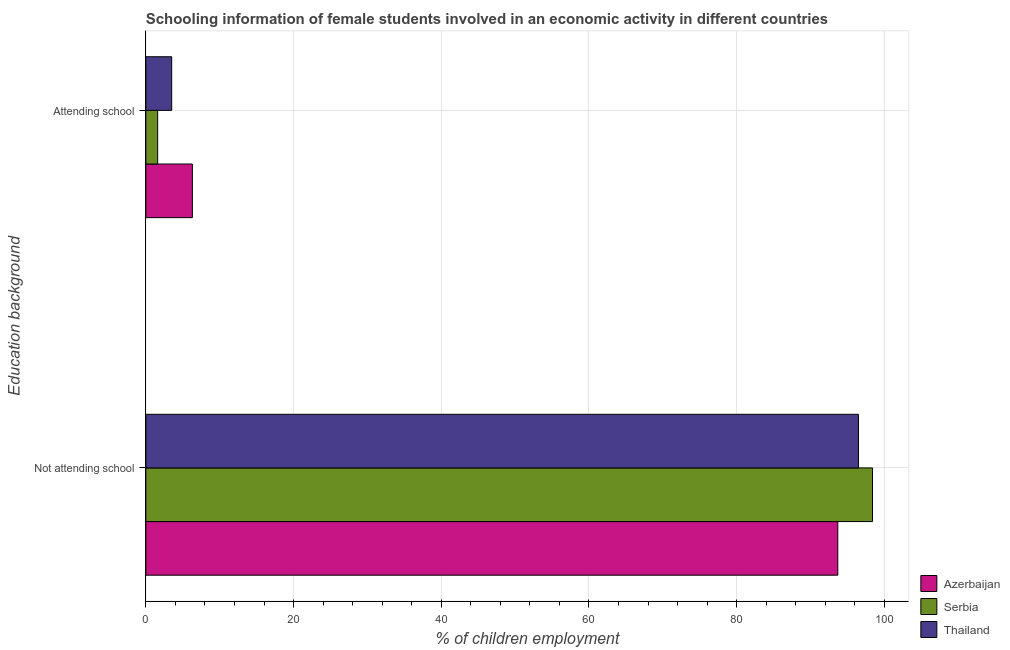Are the number of bars per tick equal to the number of legend labels?
Offer a very short reply. Yes. How many bars are there on the 2nd tick from the bottom?
Keep it short and to the point. 3. What is the label of the 1st group of bars from the top?
Offer a very short reply. Attending school. What is the percentage of employed females who are attending school in Thailand?
Your answer should be compact. 3.5. Across all countries, what is the maximum percentage of employed females who are not attending school?
Keep it short and to the point. 98.4. Across all countries, what is the minimum percentage of employed females who are not attending school?
Ensure brevity in your answer.  93.7. In which country was the percentage of employed females who are attending school maximum?
Offer a terse response. Azerbaijan. In which country was the percentage of employed females who are attending school minimum?
Your answer should be compact. Serbia. What is the total percentage of employed females who are attending school in the graph?
Your response must be concise. 11.4. What is the difference between the percentage of employed females who are attending school in Azerbaijan and that in Thailand?
Make the answer very short. 2.8. What is the difference between the percentage of employed females who are not attending school in Serbia and the percentage of employed females who are attending school in Thailand?
Your answer should be compact. 94.9. What is the average percentage of employed females who are not attending school per country?
Ensure brevity in your answer.  96.2. What is the difference between the percentage of employed females who are attending school and percentage of employed females who are not attending school in Serbia?
Make the answer very short. -96.8. What is the ratio of the percentage of employed females who are not attending school in Azerbaijan to that in Thailand?
Your response must be concise. 0.97. Is the percentage of employed females who are not attending school in Azerbaijan less than that in Thailand?
Your response must be concise. Yes. What does the 2nd bar from the top in Not attending school represents?
Your answer should be compact. Serbia. What does the 3rd bar from the bottom in Attending school represents?
Make the answer very short. Thailand. How many countries are there in the graph?
Your response must be concise. 3. Are the values on the major ticks of X-axis written in scientific E-notation?
Give a very brief answer. No. Does the graph contain any zero values?
Offer a terse response. No. Does the graph contain grids?
Offer a terse response. Yes. Where does the legend appear in the graph?
Give a very brief answer. Bottom right. How are the legend labels stacked?
Your answer should be very brief. Vertical. What is the title of the graph?
Offer a terse response. Schooling information of female students involved in an economic activity in different countries. What is the label or title of the X-axis?
Keep it short and to the point. % of children employment. What is the label or title of the Y-axis?
Provide a succinct answer. Education background. What is the % of children employment in Azerbaijan in Not attending school?
Your answer should be very brief. 93.7. What is the % of children employment of Serbia in Not attending school?
Keep it short and to the point. 98.4. What is the % of children employment in Thailand in Not attending school?
Give a very brief answer. 96.5. What is the % of children employment of Thailand in Attending school?
Ensure brevity in your answer.  3.5. Across all Education background, what is the maximum % of children employment in Azerbaijan?
Your answer should be very brief. 93.7. Across all Education background, what is the maximum % of children employment of Serbia?
Make the answer very short. 98.4. Across all Education background, what is the maximum % of children employment in Thailand?
Give a very brief answer. 96.5. Across all Education background, what is the minimum % of children employment of Serbia?
Give a very brief answer. 1.6. Across all Education background, what is the minimum % of children employment in Thailand?
Give a very brief answer. 3.5. What is the total % of children employment in Azerbaijan in the graph?
Your answer should be compact. 100. What is the total % of children employment of Serbia in the graph?
Offer a terse response. 100. What is the total % of children employment of Thailand in the graph?
Offer a terse response. 100. What is the difference between the % of children employment in Azerbaijan in Not attending school and that in Attending school?
Make the answer very short. 87.4. What is the difference between the % of children employment in Serbia in Not attending school and that in Attending school?
Give a very brief answer. 96.8. What is the difference between the % of children employment of Thailand in Not attending school and that in Attending school?
Give a very brief answer. 93. What is the difference between the % of children employment of Azerbaijan in Not attending school and the % of children employment of Serbia in Attending school?
Make the answer very short. 92.1. What is the difference between the % of children employment in Azerbaijan in Not attending school and the % of children employment in Thailand in Attending school?
Make the answer very short. 90.2. What is the difference between the % of children employment of Serbia in Not attending school and the % of children employment of Thailand in Attending school?
Your answer should be compact. 94.9. What is the average % of children employment in Serbia per Education background?
Provide a succinct answer. 50. What is the average % of children employment of Thailand per Education background?
Provide a short and direct response. 50. What is the difference between the % of children employment of Azerbaijan and % of children employment of Serbia in Not attending school?
Offer a terse response. -4.7. What is the difference between the % of children employment in Serbia and % of children employment in Thailand in Attending school?
Your answer should be compact. -1.9. What is the ratio of the % of children employment of Azerbaijan in Not attending school to that in Attending school?
Give a very brief answer. 14.87. What is the ratio of the % of children employment in Serbia in Not attending school to that in Attending school?
Give a very brief answer. 61.5. What is the ratio of the % of children employment of Thailand in Not attending school to that in Attending school?
Provide a succinct answer. 27.57. What is the difference between the highest and the second highest % of children employment of Azerbaijan?
Your answer should be very brief. 87.4. What is the difference between the highest and the second highest % of children employment in Serbia?
Offer a terse response. 96.8. What is the difference between the highest and the second highest % of children employment in Thailand?
Provide a short and direct response. 93. What is the difference between the highest and the lowest % of children employment of Azerbaijan?
Provide a succinct answer. 87.4. What is the difference between the highest and the lowest % of children employment of Serbia?
Offer a very short reply. 96.8. What is the difference between the highest and the lowest % of children employment in Thailand?
Offer a terse response. 93. 